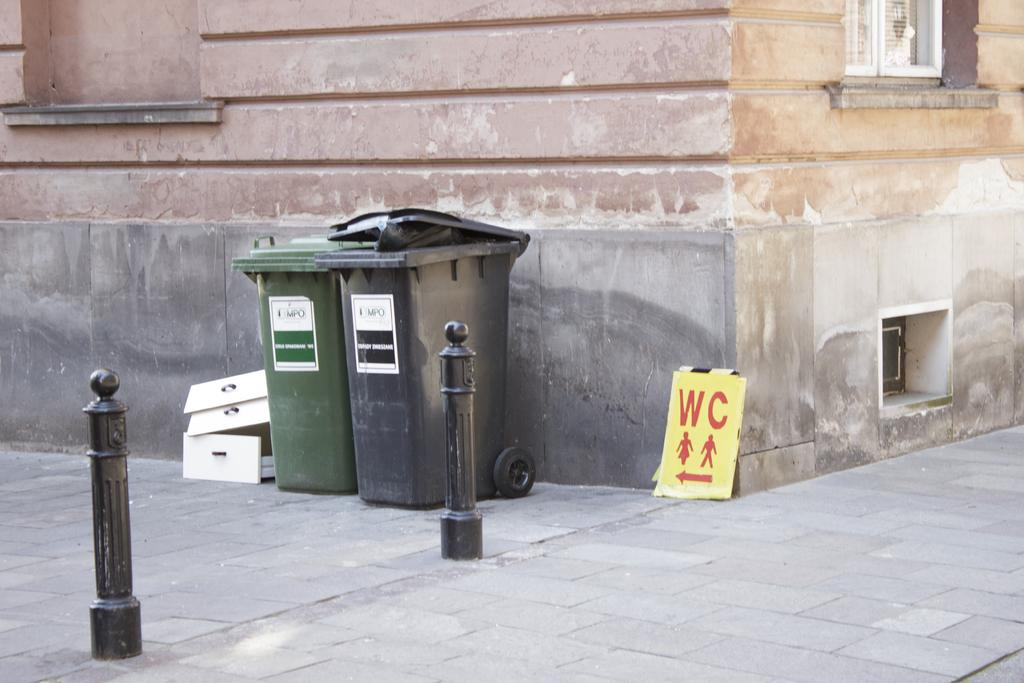<image>
Create a compact narrative representing the image presented. Two trash containers with three boxes stacked next to them on a corner with a sign that reads W and C over female and male symbols. 